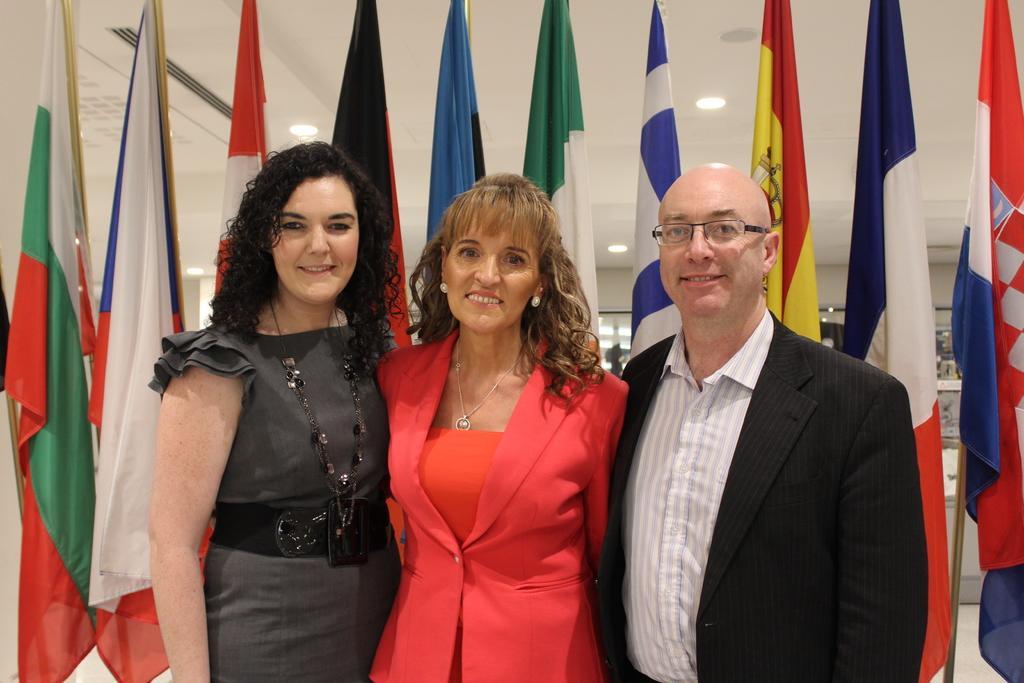Can you describe this image briefly? In this image I can see a man and two women are standing in front. I can also see smile on their faces and in the background I can see number of flags and lights on ceiling. 